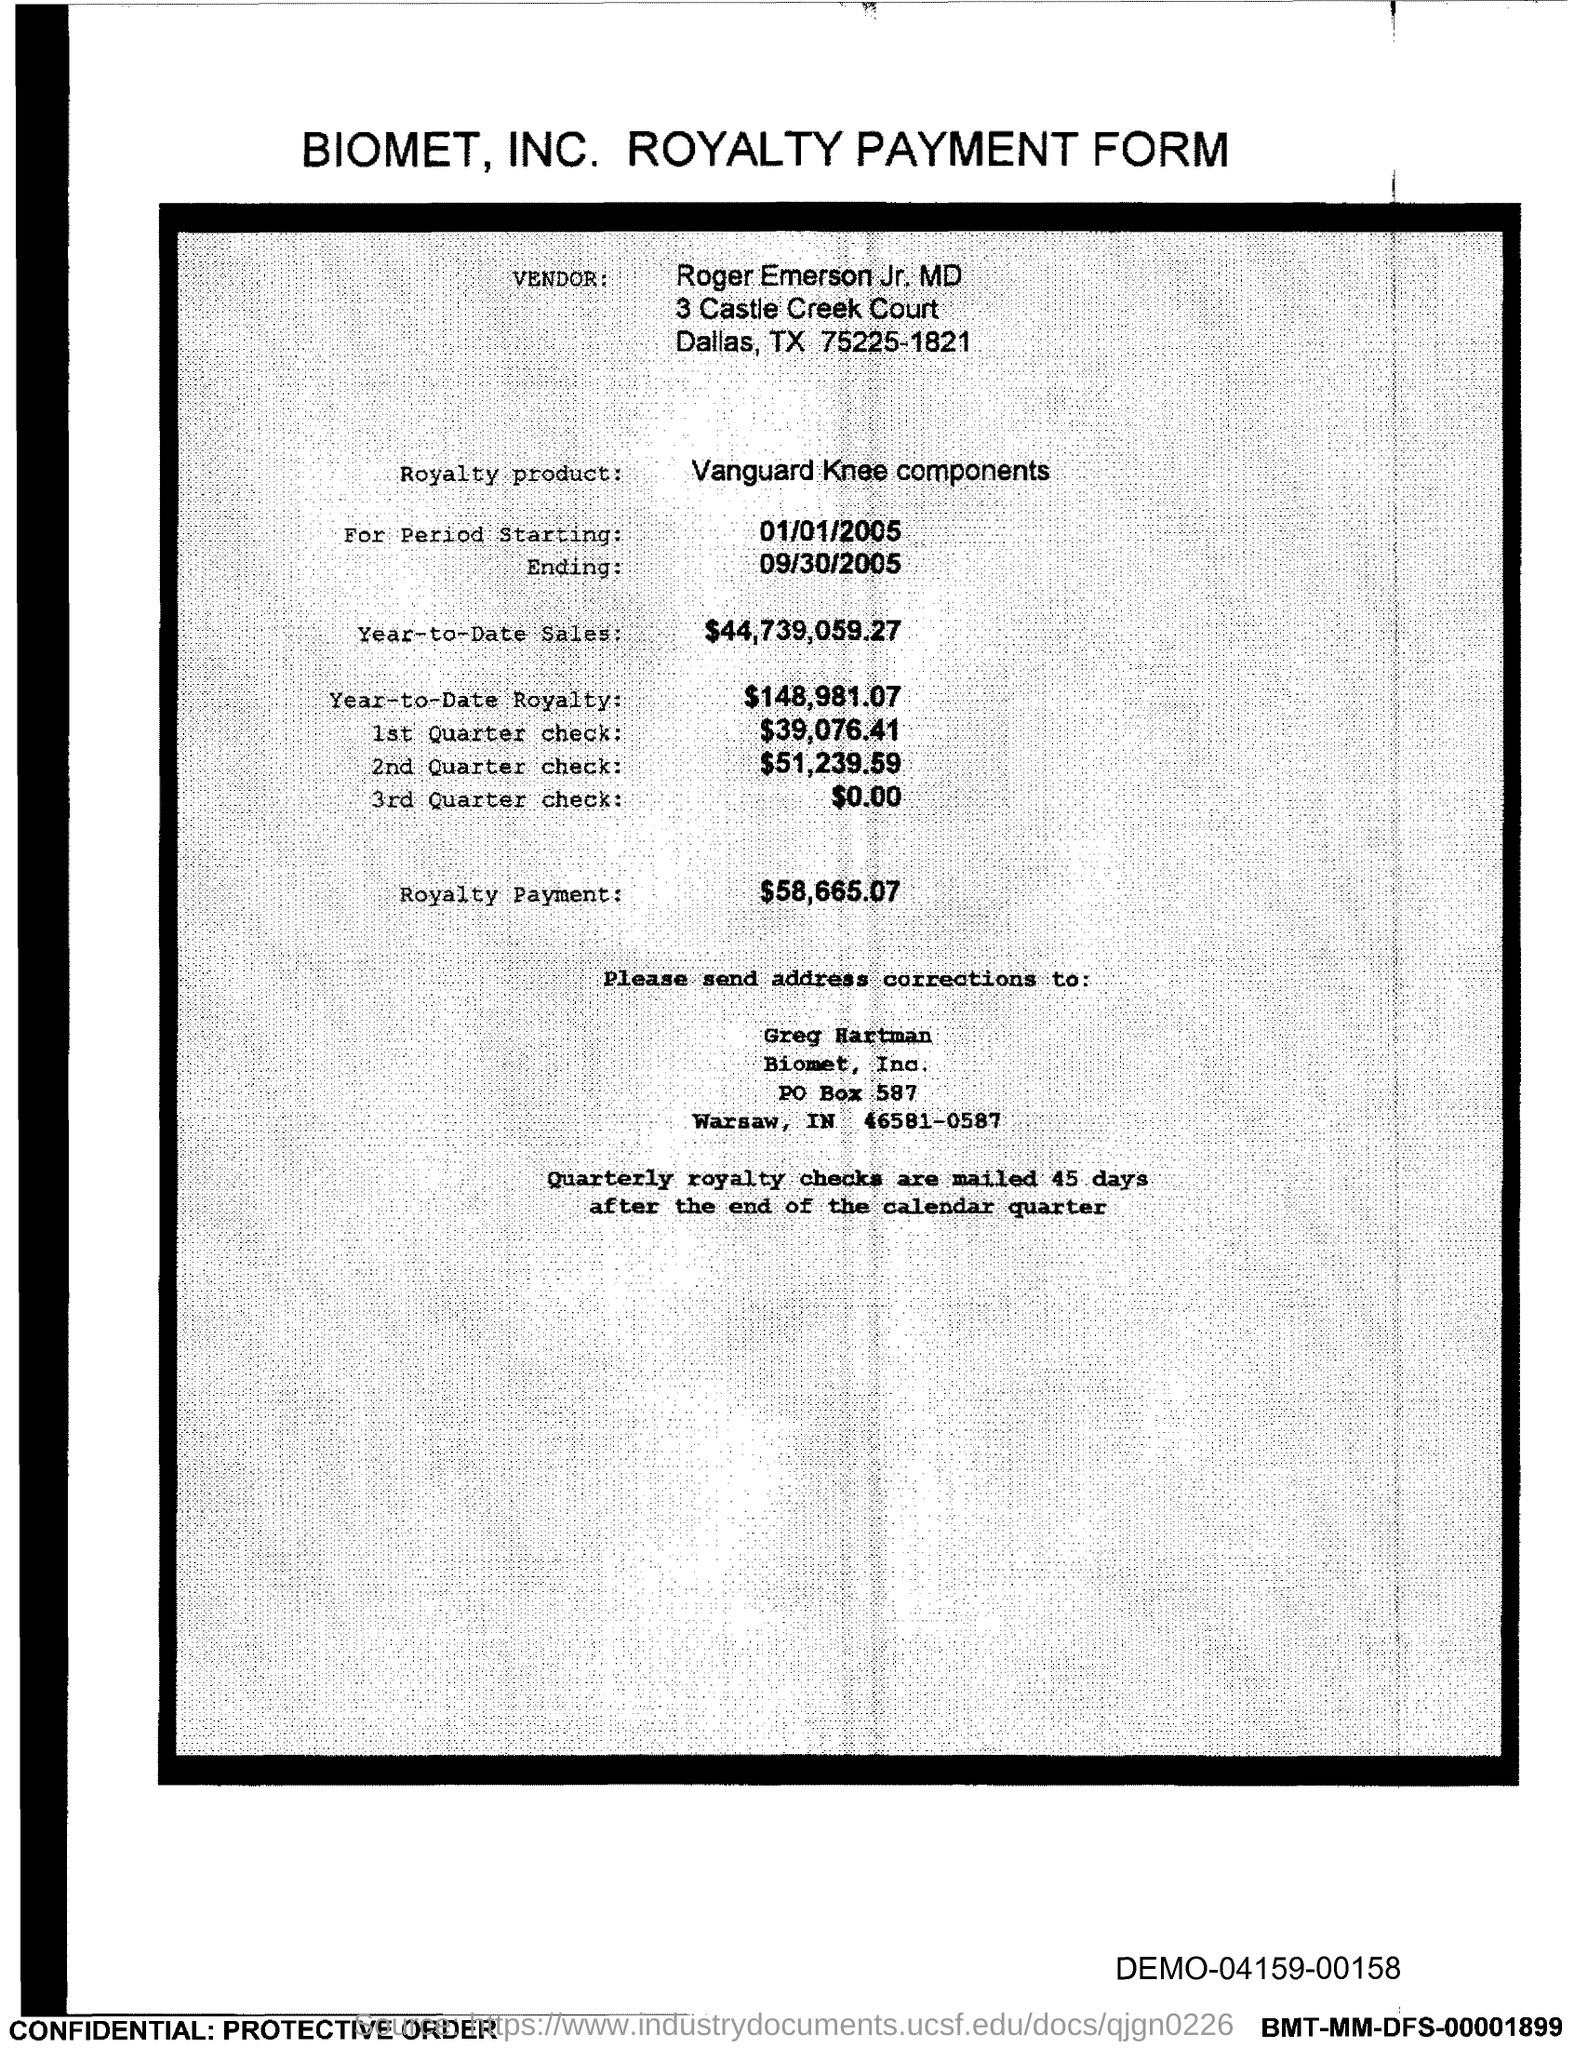Indicate a few pertinent items in this graphic. The PO Box number mentioned in the document is 587. 